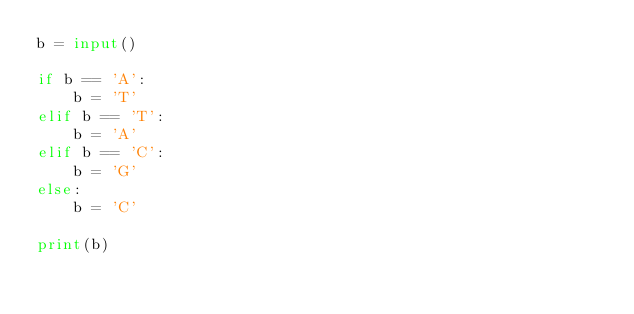Convert code to text. <code><loc_0><loc_0><loc_500><loc_500><_Python_>b = input()

if b == 'A':
    b = 'T'
elif b == 'T':
    b = 'A'
elif b == 'C':
    b = 'G'
else:
    b = 'C'

print(b)</code> 